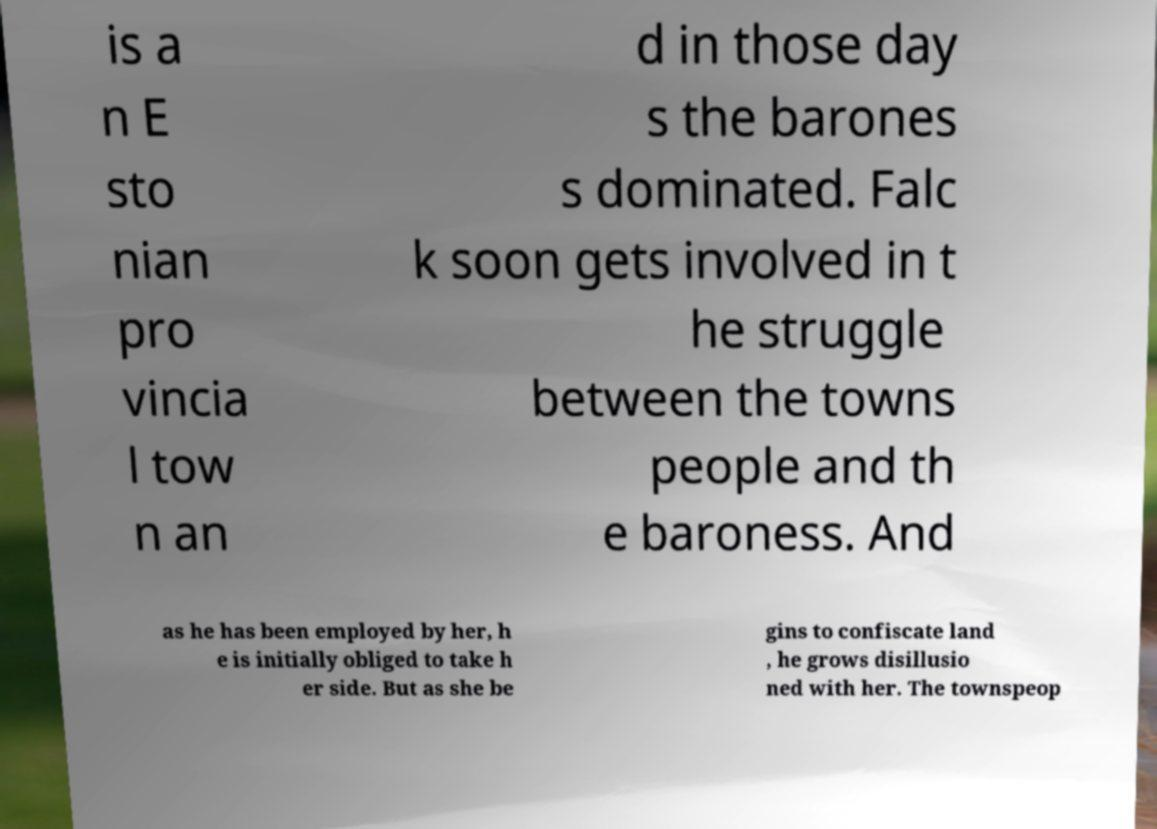What messages or text are displayed in this image? I need them in a readable, typed format. is a n E sto nian pro vincia l tow n an d in those day s the barones s dominated. Falc k soon gets involved in t he struggle between the towns people and th e baroness. And as he has been employed by her, h e is initially obliged to take h er side. But as she be gins to confiscate land , he grows disillusio ned with her. The townspeop 